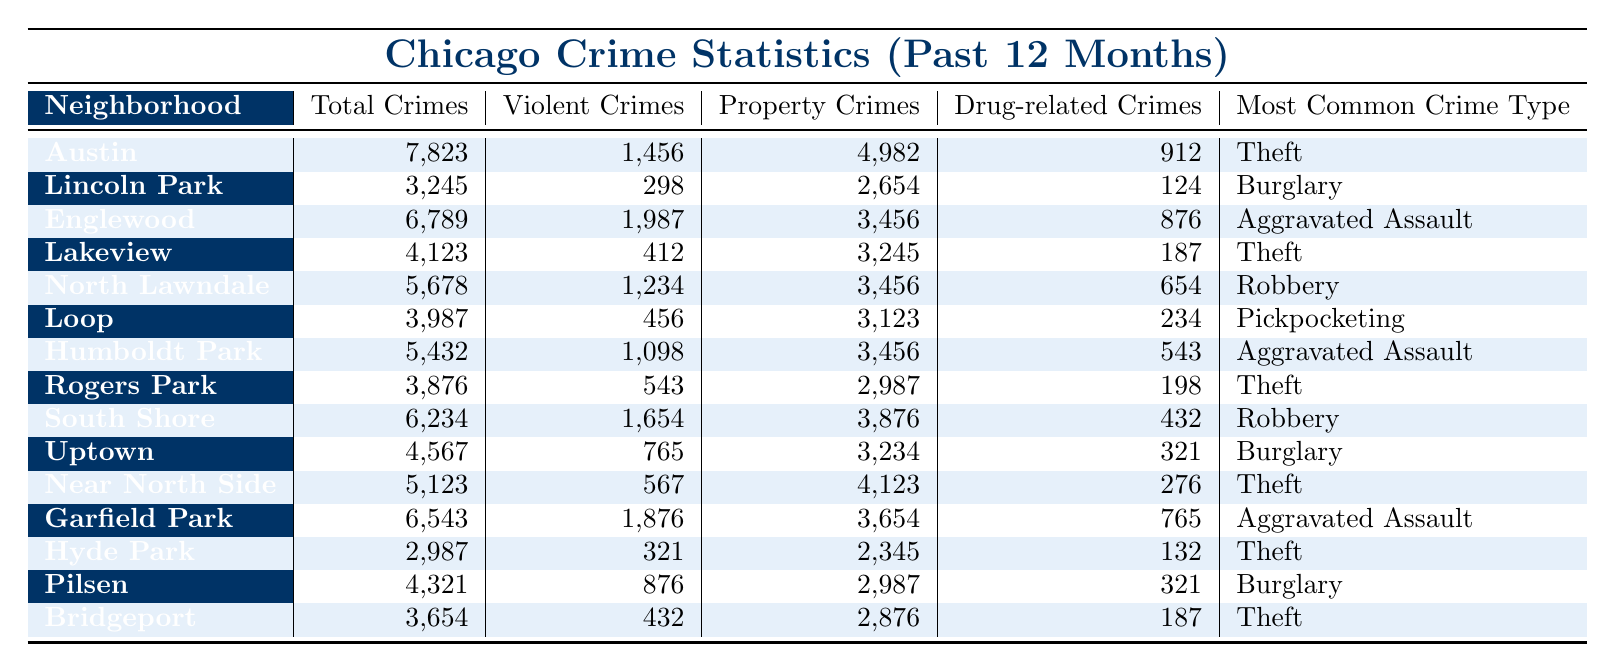What is the total number of crimes reported in the Austin neighborhood? The table indicates that Austin has a total of 7,823 reported crimes.
Answer: 7,823 Which neighborhood has the highest count of violent crimes? By scanning the "Violent Crimes" column, Englewood shows the highest total at 1,987.
Answer: Englewood What percentage of total crimes in Lincoln Park are violent crimes? Lincoln Park has 3,245 total crimes, with 298 classified as violent. The percentage is (298/3245) * 100 ≈ 9.2%.
Answer: Approximately 9.2% How many property crimes were reported in total across all neighborhoods? The sum of property crimes for all neighborhoods is calculated: 4,982 + 2,654 + 3,456 + 3,245 + 3,456 + 3,123 + 3,456 + 2,987 + 3,876 + 3,234 + 4,123 + 3,654 + 2,345 + 2,987 + 2,876 = 50,121.
Answer: 50,121 Which neighborhood has the least number of total crimes? Observing the "Total Crimes" column, Hyde Park has the lowest figure at 2,987.
Answer: Hyde Park Is the most common crime type in Rogers Park Theft? The table shows that the most common crime in Rogers Park is Theft, so the statement is true.
Answer: Yes What is the difference in total crimes between Garfield Park and Lakeview? Garfield Park has 6,543 total crimes while Lakeview has 4,123. The difference is 6,543 - 4,123 = 2,420.
Answer: 2,420 Which neighborhood is known for having the most reported drug-related crimes? Reviewing the "Drug-related Crimes" column, Austin has the highest count with 912 drug-related offenses.
Answer: Austin If we average the number of violent crimes across all neighborhoods listed, what is the average? The violent crimes data are 1,456; 298; 1,987; 412; 1,234; 456; 1,098; 543; 1,654; 765; 567; 1,876; 321; 876; and 432. Summing these gives a total of 12,126, which divided by 15 neighborhoods yields an average of 808.4.
Answer: Approximately 808.4 Which neighborhoods have the same most common crime type as North Lawndale? North Lawndale lists Robbery as its most common crime type. By checking other neighborhoods, we find that South Shore also lists Robbery.
Answer: South Shore 